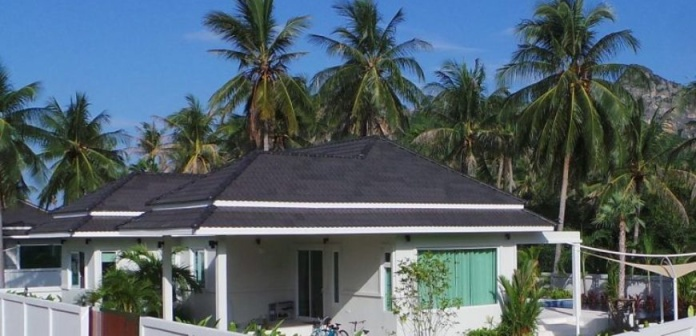What sort of activities might one do in this location? In such a picturesque tropical setting, one might engage in a variety of activities. The bicycles suggest that cycling around to explore the local landscape is popular. The nearby mountains and lush greenery also provide opportunities for hiking and nature walks. The calm environment is perfect for relaxation, perhaps reading in the garden or enjoying a leisurely brunch on a patio with views of the palm trees and mountains. Depending on the proximity to the coast, water activities like swimming, snorkeling, or beachcombing could also be on the list. 